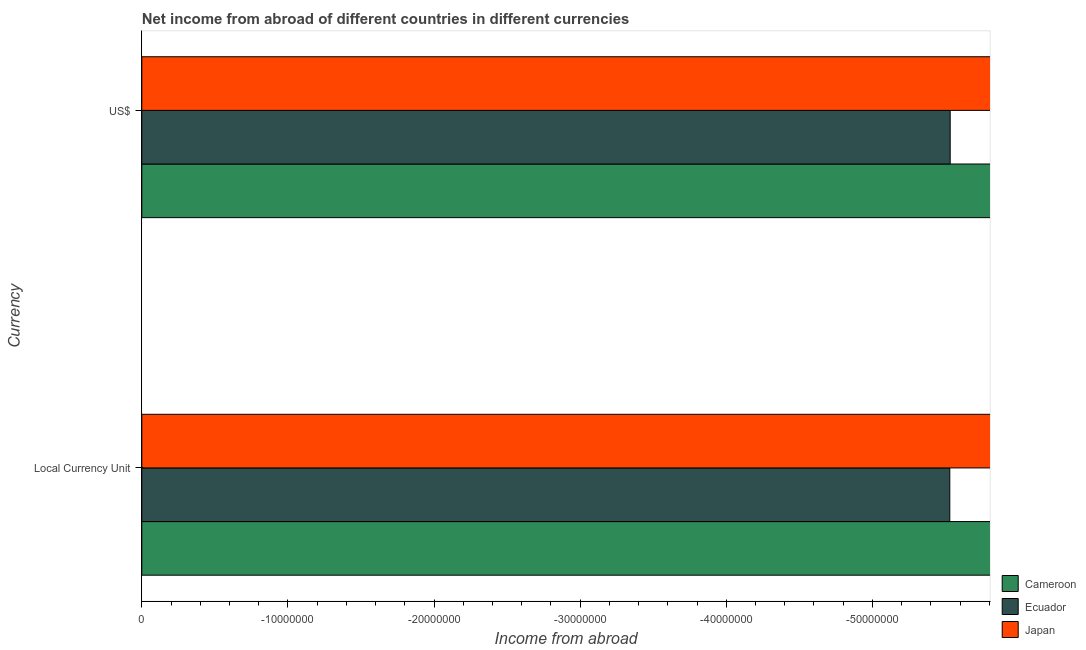How many bars are there on the 2nd tick from the top?
Offer a very short reply. 0. What is the label of the 1st group of bars from the top?
Your answer should be very brief. US$. What is the income from abroad in us$ in Ecuador?
Provide a succinct answer. 0. What is the total income from abroad in constant 2005 us$ in the graph?
Your response must be concise. 0. What is the difference between the income from abroad in us$ in Ecuador and the income from abroad in constant 2005 us$ in Japan?
Keep it short and to the point. 0. In how many countries, is the income from abroad in us$ greater than -2000000 units?
Your answer should be compact. 0. How many bars are there?
Offer a very short reply. 0. What is the difference between two consecutive major ticks on the X-axis?
Give a very brief answer. 1.00e+07. Are the values on the major ticks of X-axis written in scientific E-notation?
Offer a very short reply. No. Where does the legend appear in the graph?
Provide a succinct answer. Bottom right. How many legend labels are there?
Your response must be concise. 3. How are the legend labels stacked?
Keep it short and to the point. Vertical. What is the title of the graph?
Ensure brevity in your answer.  Net income from abroad of different countries in different currencies. Does "Singapore" appear as one of the legend labels in the graph?
Keep it short and to the point. No. What is the label or title of the X-axis?
Offer a very short reply. Income from abroad. What is the label or title of the Y-axis?
Your answer should be compact. Currency. What is the Income from abroad in Cameroon in Local Currency Unit?
Keep it short and to the point. 0. What is the Income from abroad in Japan in Local Currency Unit?
Ensure brevity in your answer.  0. What is the Income from abroad of Cameroon in US$?
Your answer should be very brief. 0. What is the Income from abroad in Ecuador in US$?
Your answer should be compact. 0. What is the Income from abroad in Japan in US$?
Give a very brief answer. 0. What is the total Income from abroad of Cameroon in the graph?
Offer a very short reply. 0. What is the total Income from abroad in Ecuador in the graph?
Provide a short and direct response. 0. What is the total Income from abroad of Japan in the graph?
Ensure brevity in your answer.  0. What is the average Income from abroad of Ecuador per Currency?
Your response must be concise. 0. 